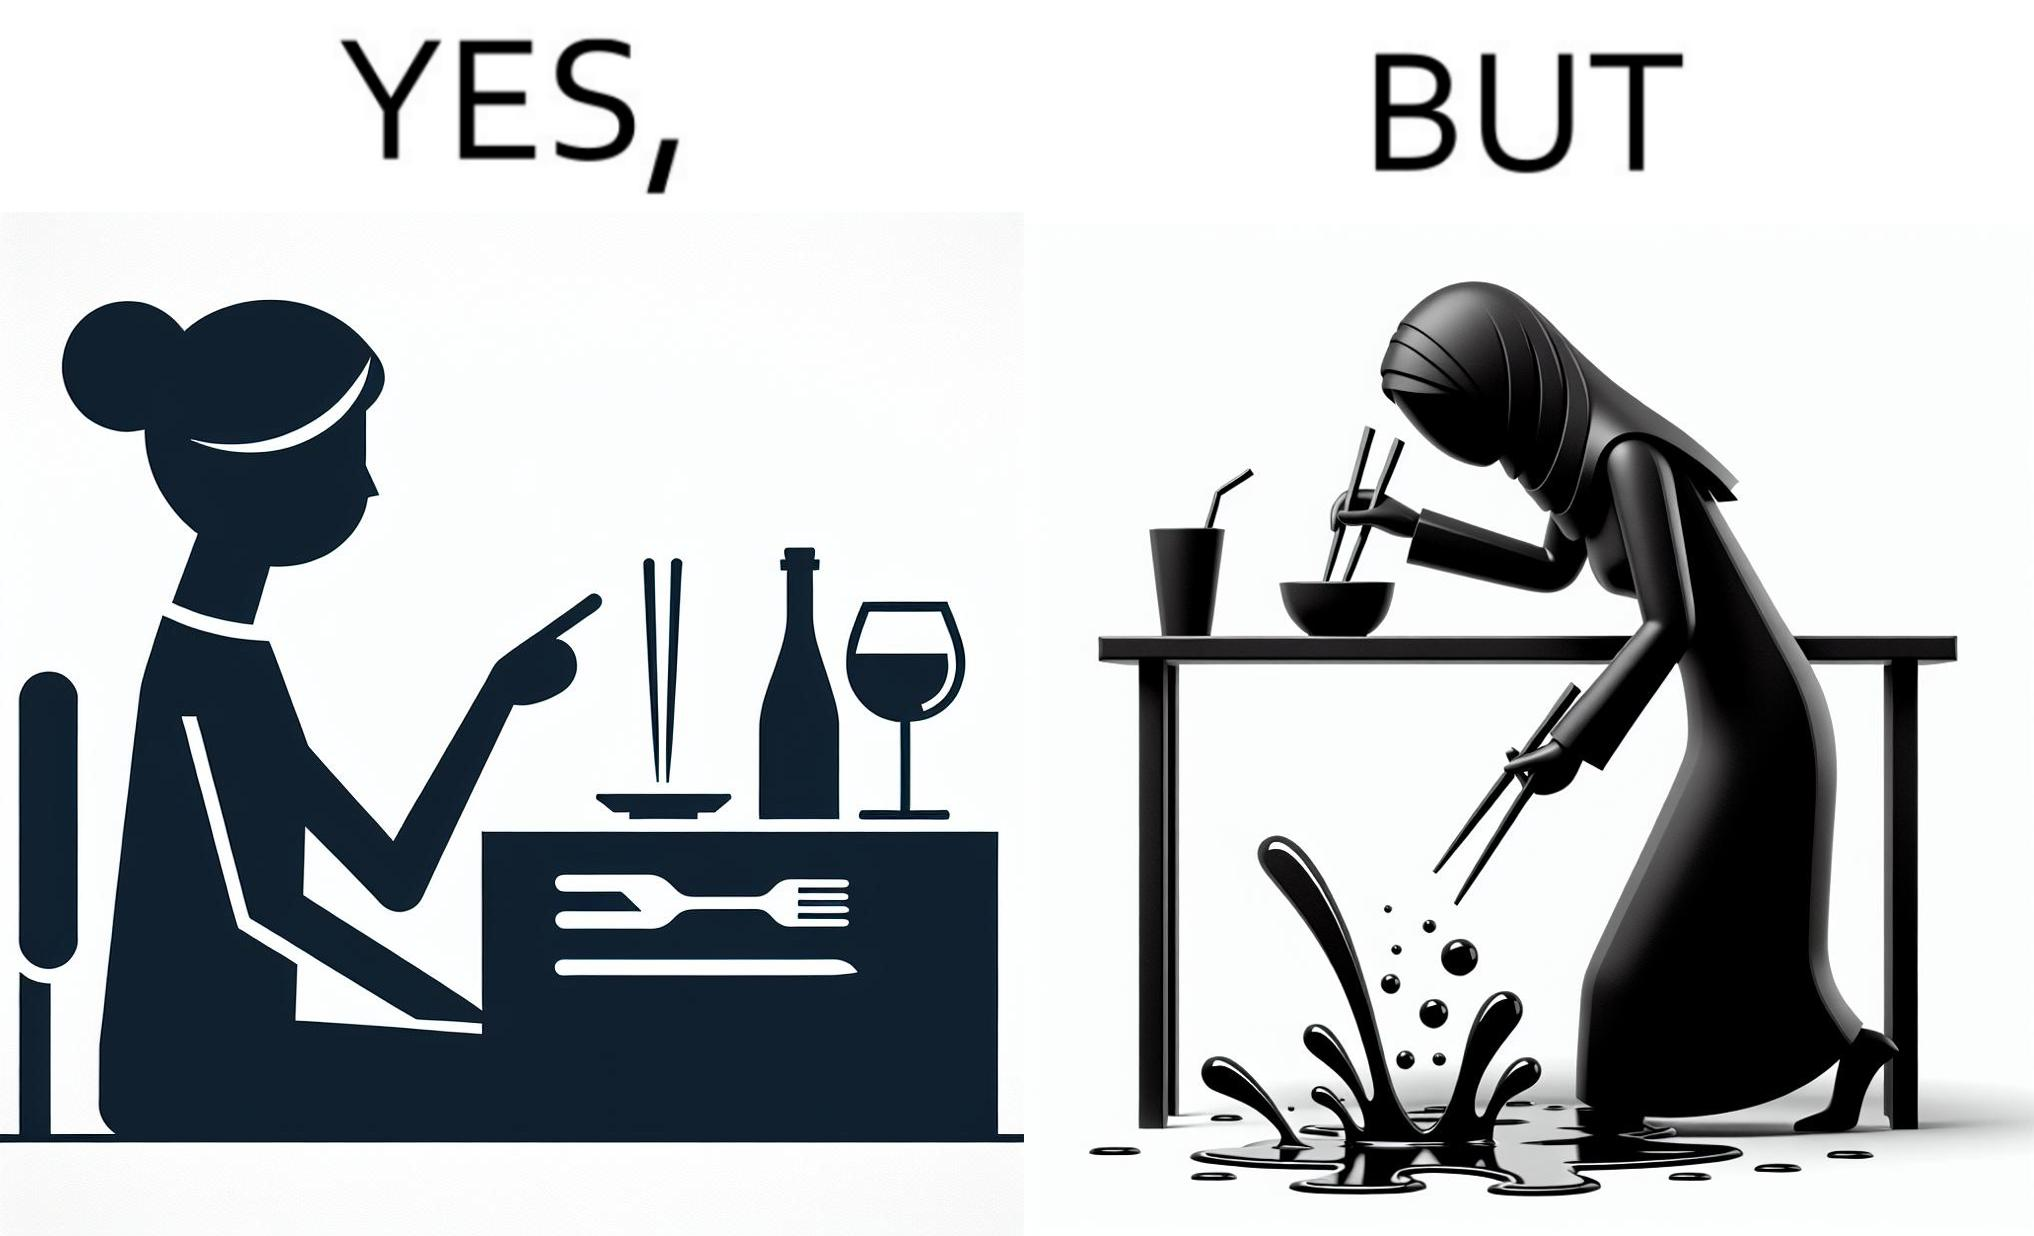Describe the satirical element in this image. The image is satirical because even thought the woman is not able to eat food with chopstick properly, she chooses it over fork and knife to look sophisticaed. 